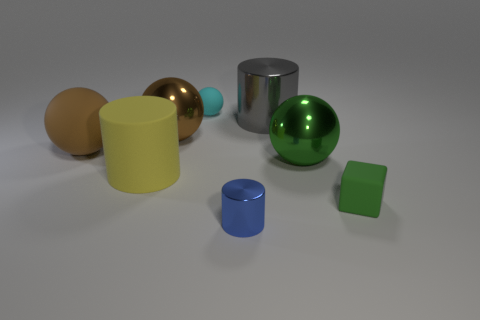Subtract all gray cylinders. How many cylinders are left? 2 Subtract all purple cylinders. How many brown balls are left? 2 Subtract all cyan balls. How many balls are left? 3 Subtract 1 spheres. How many spheres are left? 3 Add 1 brown metal balls. How many objects exist? 9 Subtract all gray spheres. Subtract all red cylinders. How many spheres are left? 4 Add 6 tiny blue metallic objects. How many tiny blue metallic objects are left? 7 Add 1 gray cylinders. How many gray cylinders exist? 2 Subtract 1 brown spheres. How many objects are left? 7 Subtract all cubes. How many objects are left? 7 